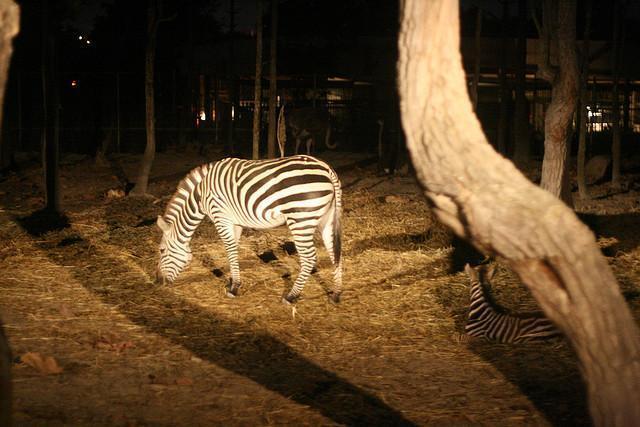How many zebras are in the picture?
Give a very brief answer. 2. How many zebras can you see?
Give a very brief answer. 2. 